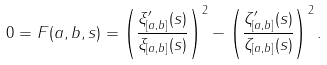Convert formula to latex. <formula><loc_0><loc_0><loc_500><loc_500>0 = F ( a , b , s ) = \left ( \frac { \xi _ { [ a , b ] } ^ { \prime } ( s ) } { \xi _ { [ a , b ] } ( s ) } \right ) ^ { 2 } - \left ( \frac { \zeta _ { [ a , b ] } ^ { \prime } ( s ) } { \zeta _ { [ a , b ] } ( s ) } \right ) ^ { 2 } .</formula> 